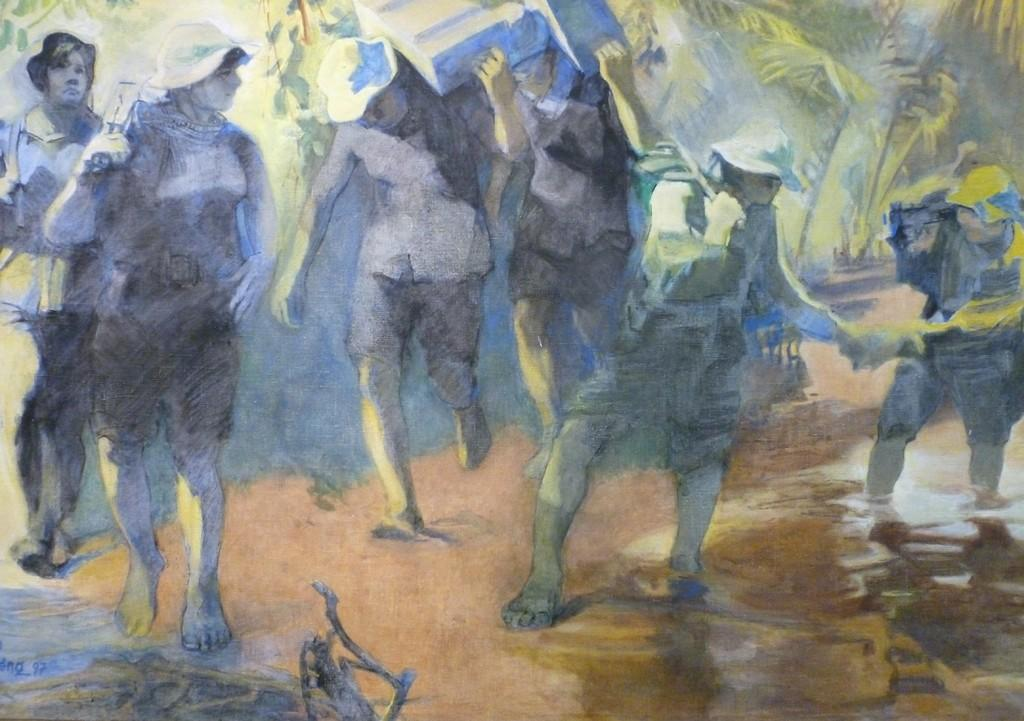What is the main subject of the image? There is a painting in the image. What is depicted in the painting? The painting depicts people. What colors are the people in the painting wearing? The people in the painting are in blue, green, white, and brown colors. What type of celery is being used to create friction on the shirt in the image? There is no celery or shirt present in the image; it features a painting depicting people in various colors. 